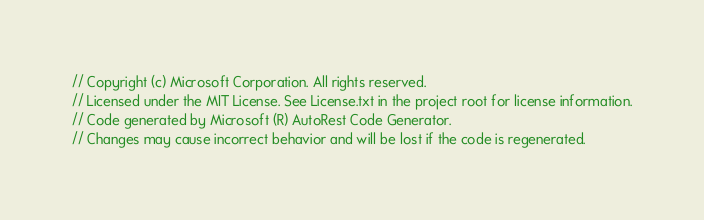Convert code to text. <code><loc_0><loc_0><loc_500><loc_500><_C#_>// Copyright (c) Microsoft Corporation. All rights reserved.
// Licensed under the MIT License. See License.txt in the project root for license information.
// Code generated by Microsoft (R) AutoRest Code Generator.
// Changes may cause incorrect behavior and will be lost if the code is regenerated.
</code> 